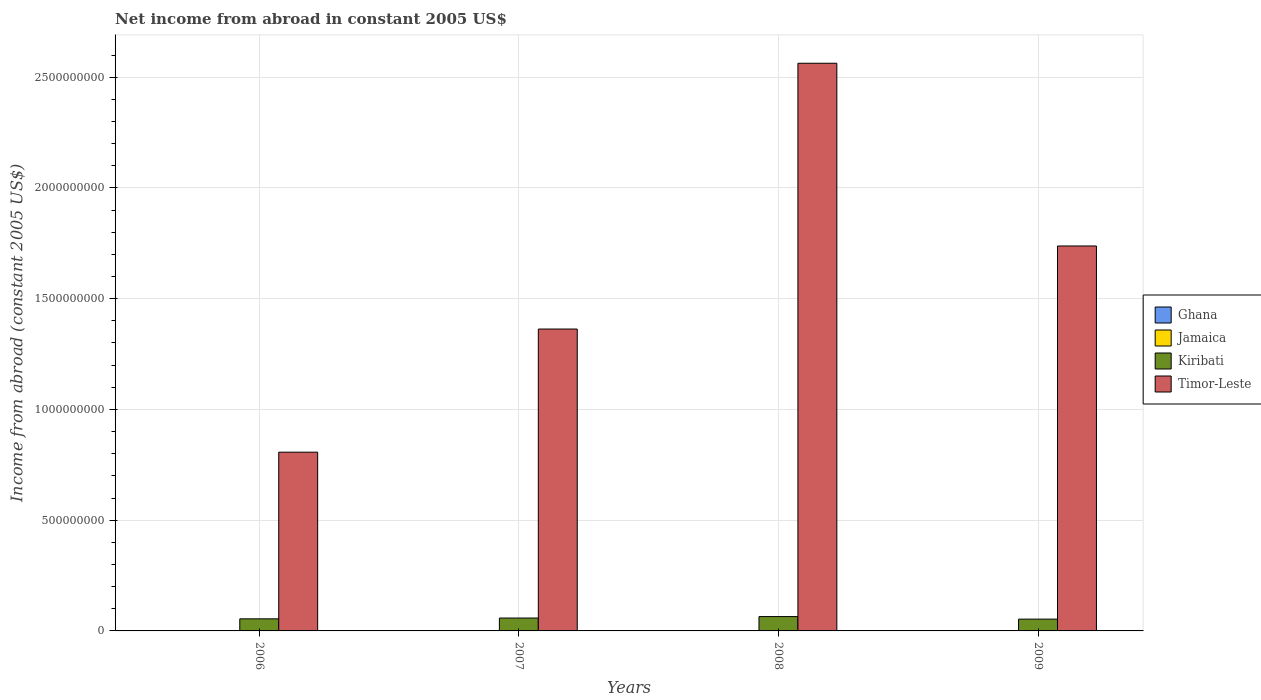Are the number of bars per tick equal to the number of legend labels?
Offer a very short reply. No. Are the number of bars on each tick of the X-axis equal?
Provide a succinct answer. Yes. In how many cases, is the number of bars for a given year not equal to the number of legend labels?
Provide a short and direct response. 4. What is the net income from abroad in Ghana in 2006?
Ensure brevity in your answer.  0. Across all years, what is the maximum net income from abroad in Kiribati?
Offer a terse response. 6.48e+07. Across all years, what is the minimum net income from abroad in Timor-Leste?
Ensure brevity in your answer.  8.07e+08. What is the total net income from abroad in Timor-Leste in the graph?
Give a very brief answer. 6.47e+09. What is the difference between the net income from abroad in Kiribati in 2007 and that in 2009?
Your answer should be very brief. 4.96e+06. What is the difference between the net income from abroad in Jamaica in 2007 and the net income from abroad in Kiribati in 2006?
Your answer should be very brief. -5.46e+07. What is the average net income from abroad in Timor-Leste per year?
Your answer should be compact. 1.62e+09. In the year 2008, what is the difference between the net income from abroad in Kiribati and net income from abroad in Timor-Leste?
Give a very brief answer. -2.50e+09. What is the ratio of the net income from abroad in Kiribati in 2006 to that in 2009?
Provide a short and direct response. 1.03. Is the difference between the net income from abroad in Kiribati in 2006 and 2008 greater than the difference between the net income from abroad in Timor-Leste in 2006 and 2008?
Your response must be concise. Yes. What is the difference between the highest and the second highest net income from abroad in Kiribati?
Provide a succinct answer. 6.60e+06. What is the difference between the highest and the lowest net income from abroad in Kiribati?
Make the answer very short. 1.16e+07. Is the sum of the net income from abroad in Timor-Leste in 2006 and 2008 greater than the maximum net income from abroad in Ghana across all years?
Keep it short and to the point. Yes. Are all the bars in the graph horizontal?
Your response must be concise. No. What is the difference between two consecutive major ticks on the Y-axis?
Your answer should be compact. 5.00e+08. Does the graph contain any zero values?
Offer a very short reply. Yes. How many legend labels are there?
Your answer should be very brief. 4. How are the legend labels stacked?
Keep it short and to the point. Vertical. What is the title of the graph?
Offer a terse response. Net income from abroad in constant 2005 US$. What is the label or title of the X-axis?
Provide a short and direct response. Years. What is the label or title of the Y-axis?
Offer a terse response. Income from abroad (constant 2005 US$). What is the Income from abroad (constant 2005 US$) in Ghana in 2006?
Keep it short and to the point. 0. What is the Income from abroad (constant 2005 US$) in Jamaica in 2006?
Your answer should be compact. 0. What is the Income from abroad (constant 2005 US$) of Kiribati in 2006?
Offer a terse response. 5.46e+07. What is the Income from abroad (constant 2005 US$) of Timor-Leste in 2006?
Offer a very short reply. 8.07e+08. What is the Income from abroad (constant 2005 US$) of Jamaica in 2007?
Make the answer very short. 0. What is the Income from abroad (constant 2005 US$) in Kiribati in 2007?
Give a very brief answer. 5.82e+07. What is the Income from abroad (constant 2005 US$) of Timor-Leste in 2007?
Give a very brief answer. 1.36e+09. What is the Income from abroad (constant 2005 US$) of Ghana in 2008?
Ensure brevity in your answer.  0. What is the Income from abroad (constant 2005 US$) of Jamaica in 2008?
Ensure brevity in your answer.  0. What is the Income from abroad (constant 2005 US$) in Kiribati in 2008?
Your response must be concise. 6.48e+07. What is the Income from abroad (constant 2005 US$) in Timor-Leste in 2008?
Offer a very short reply. 2.56e+09. What is the Income from abroad (constant 2005 US$) in Kiribati in 2009?
Give a very brief answer. 5.32e+07. What is the Income from abroad (constant 2005 US$) in Timor-Leste in 2009?
Your response must be concise. 1.74e+09. Across all years, what is the maximum Income from abroad (constant 2005 US$) of Kiribati?
Provide a succinct answer. 6.48e+07. Across all years, what is the maximum Income from abroad (constant 2005 US$) of Timor-Leste?
Your response must be concise. 2.56e+09. Across all years, what is the minimum Income from abroad (constant 2005 US$) of Kiribati?
Keep it short and to the point. 5.32e+07. Across all years, what is the minimum Income from abroad (constant 2005 US$) of Timor-Leste?
Provide a succinct answer. 8.07e+08. What is the total Income from abroad (constant 2005 US$) of Ghana in the graph?
Your answer should be compact. 0. What is the total Income from abroad (constant 2005 US$) of Jamaica in the graph?
Ensure brevity in your answer.  0. What is the total Income from abroad (constant 2005 US$) in Kiribati in the graph?
Your answer should be very brief. 2.31e+08. What is the total Income from abroad (constant 2005 US$) in Timor-Leste in the graph?
Give a very brief answer. 6.47e+09. What is the difference between the Income from abroad (constant 2005 US$) in Kiribati in 2006 and that in 2007?
Keep it short and to the point. -3.56e+06. What is the difference between the Income from abroad (constant 2005 US$) of Timor-Leste in 2006 and that in 2007?
Offer a terse response. -5.56e+08. What is the difference between the Income from abroad (constant 2005 US$) of Kiribati in 2006 and that in 2008?
Your answer should be very brief. -1.02e+07. What is the difference between the Income from abroad (constant 2005 US$) of Timor-Leste in 2006 and that in 2008?
Ensure brevity in your answer.  -1.76e+09. What is the difference between the Income from abroad (constant 2005 US$) of Kiribati in 2006 and that in 2009?
Offer a terse response. 1.40e+06. What is the difference between the Income from abroad (constant 2005 US$) of Timor-Leste in 2006 and that in 2009?
Offer a very short reply. -9.31e+08. What is the difference between the Income from abroad (constant 2005 US$) of Kiribati in 2007 and that in 2008?
Make the answer very short. -6.60e+06. What is the difference between the Income from abroad (constant 2005 US$) in Timor-Leste in 2007 and that in 2008?
Give a very brief answer. -1.20e+09. What is the difference between the Income from abroad (constant 2005 US$) in Kiribati in 2007 and that in 2009?
Provide a short and direct response. 4.96e+06. What is the difference between the Income from abroad (constant 2005 US$) in Timor-Leste in 2007 and that in 2009?
Make the answer very short. -3.75e+08. What is the difference between the Income from abroad (constant 2005 US$) of Kiribati in 2008 and that in 2009?
Offer a terse response. 1.16e+07. What is the difference between the Income from abroad (constant 2005 US$) in Timor-Leste in 2008 and that in 2009?
Ensure brevity in your answer.  8.25e+08. What is the difference between the Income from abroad (constant 2005 US$) in Kiribati in 2006 and the Income from abroad (constant 2005 US$) in Timor-Leste in 2007?
Your answer should be very brief. -1.31e+09. What is the difference between the Income from abroad (constant 2005 US$) of Kiribati in 2006 and the Income from abroad (constant 2005 US$) of Timor-Leste in 2008?
Ensure brevity in your answer.  -2.51e+09. What is the difference between the Income from abroad (constant 2005 US$) of Kiribati in 2006 and the Income from abroad (constant 2005 US$) of Timor-Leste in 2009?
Your answer should be very brief. -1.68e+09. What is the difference between the Income from abroad (constant 2005 US$) of Kiribati in 2007 and the Income from abroad (constant 2005 US$) of Timor-Leste in 2008?
Offer a terse response. -2.50e+09. What is the difference between the Income from abroad (constant 2005 US$) of Kiribati in 2007 and the Income from abroad (constant 2005 US$) of Timor-Leste in 2009?
Provide a succinct answer. -1.68e+09. What is the difference between the Income from abroad (constant 2005 US$) of Kiribati in 2008 and the Income from abroad (constant 2005 US$) of Timor-Leste in 2009?
Provide a short and direct response. -1.67e+09. What is the average Income from abroad (constant 2005 US$) of Ghana per year?
Your answer should be very brief. 0. What is the average Income from abroad (constant 2005 US$) in Kiribati per year?
Your answer should be very brief. 5.77e+07. What is the average Income from abroad (constant 2005 US$) of Timor-Leste per year?
Offer a terse response. 1.62e+09. In the year 2006, what is the difference between the Income from abroad (constant 2005 US$) in Kiribati and Income from abroad (constant 2005 US$) in Timor-Leste?
Provide a short and direct response. -7.52e+08. In the year 2007, what is the difference between the Income from abroad (constant 2005 US$) in Kiribati and Income from abroad (constant 2005 US$) in Timor-Leste?
Provide a succinct answer. -1.30e+09. In the year 2008, what is the difference between the Income from abroad (constant 2005 US$) of Kiribati and Income from abroad (constant 2005 US$) of Timor-Leste?
Provide a short and direct response. -2.50e+09. In the year 2009, what is the difference between the Income from abroad (constant 2005 US$) in Kiribati and Income from abroad (constant 2005 US$) in Timor-Leste?
Provide a succinct answer. -1.68e+09. What is the ratio of the Income from abroad (constant 2005 US$) of Kiribati in 2006 to that in 2007?
Provide a succinct answer. 0.94. What is the ratio of the Income from abroad (constant 2005 US$) of Timor-Leste in 2006 to that in 2007?
Provide a short and direct response. 0.59. What is the ratio of the Income from abroad (constant 2005 US$) of Kiribati in 2006 to that in 2008?
Ensure brevity in your answer.  0.84. What is the ratio of the Income from abroad (constant 2005 US$) of Timor-Leste in 2006 to that in 2008?
Provide a short and direct response. 0.31. What is the ratio of the Income from abroad (constant 2005 US$) in Kiribati in 2006 to that in 2009?
Your answer should be compact. 1.03. What is the ratio of the Income from abroad (constant 2005 US$) in Timor-Leste in 2006 to that in 2009?
Your answer should be compact. 0.46. What is the ratio of the Income from abroad (constant 2005 US$) in Kiribati in 2007 to that in 2008?
Provide a succinct answer. 0.9. What is the ratio of the Income from abroad (constant 2005 US$) of Timor-Leste in 2007 to that in 2008?
Provide a short and direct response. 0.53. What is the ratio of the Income from abroad (constant 2005 US$) of Kiribati in 2007 to that in 2009?
Your response must be concise. 1.09. What is the ratio of the Income from abroad (constant 2005 US$) of Timor-Leste in 2007 to that in 2009?
Offer a very short reply. 0.78. What is the ratio of the Income from abroad (constant 2005 US$) in Kiribati in 2008 to that in 2009?
Make the answer very short. 1.22. What is the ratio of the Income from abroad (constant 2005 US$) in Timor-Leste in 2008 to that in 2009?
Offer a very short reply. 1.47. What is the difference between the highest and the second highest Income from abroad (constant 2005 US$) of Kiribati?
Your answer should be very brief. 6.60e+06. What is the difference between the highest and the second highest Income from abroad (constant 2005 US$) of Timor-Leste?
Offer a very short reply. 8.25e+08. What is the difference between the highest and the lowest Income from abroad (constant 2005 US$) of Kiribati?
Give a very brief answer. 1.16e+07. What is the difference between the highest and the lowest Income from abroad (constant 2005 US$) in Timor-Leste?
Offer a terse response. 1.76e+09. 